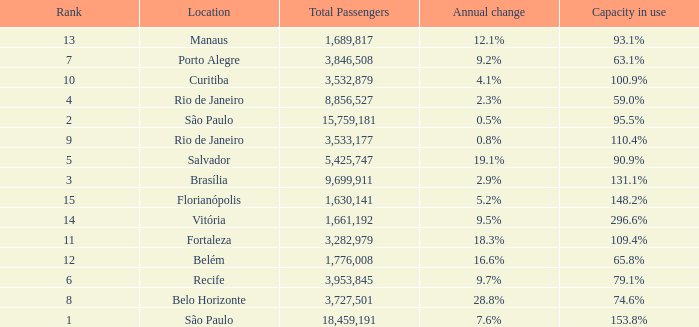What is the highest Total Passengers when the annual change is 18.3%, and the rank is less than 11? None. 